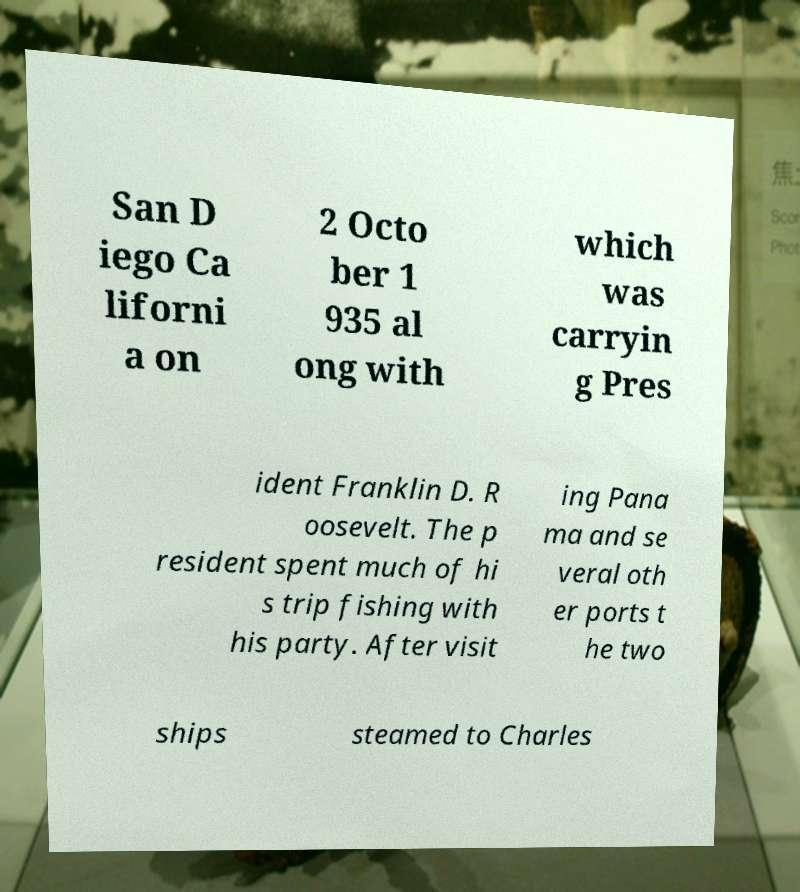Please read and relay the text visible in this image. What does it say? San D iego Ca liforni a on 2 Octo ber 1 935 al ong with which was carryin g Pres ident Franklin D. R oosevelt. The p resident spent much of hi s trip fishing with his party. After visit ing Pana ma and se veral oth er ports t he two ships steamed to Charles 